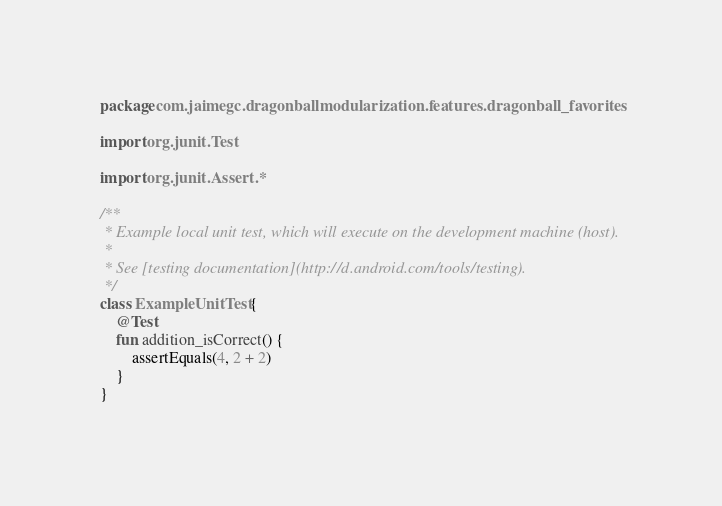<code> <loc_0><loc_0><loc_500><loc_500><_Kotlin_>package com.jaimegc.dragonballmodularization.features.dragonball_favorites

import org.junit.Test

import org.junit.Assert.*

/**
 * Example local unit test, which will execute on the development machine (host).
 *
 * See [testing documentation](http://d.android.com/tools/testing).
 */
class ExampleUnitTest {
    @Test
    fun addition_isCorrect() {
        assertEquals(4, 2 + 2)
    }
}</code> 